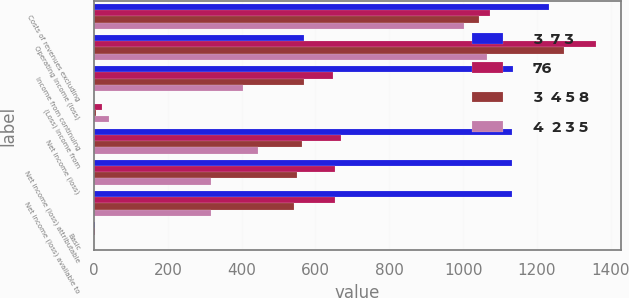Convert chart. <chart><loc_0><loc_0><loc_500><loc_500><stacked_bar_chart><ecel><fcel>Costs of revenues excluding<fcel>Operating income (loss)<fcel>Income from continuing<fcel>(Loss) income from<fcel>Net income (loss)<fcel>Net income (loss) attributable<fcel>Net income (loss) available to<fcel>Basic<nl><fcel>3  7 3<fcel>1233<fcel>570<fcel>1134<fcel>1<fcel>1133<fcel>1132<fcel>1132<fcel>2.82<nl><fcel>76<fcel>1073<fcel>1360<fcel>647<fcel>22<fcel>669<fcel>653<fcel>652<fcel>1.48<nl><fcel>3  4 5 8<fcel>1044<fcel>1274<fcel>570<fcel>6<fcel>564<fcel>549<fcel>541<fcel>1.29<nl><fcel>4  2 3 5<fcel>1002<fcel>1064<fcel>404<fcel>40<fcel>444<fcel>317<fcel>317<fcel>0.86<nl></chart> 